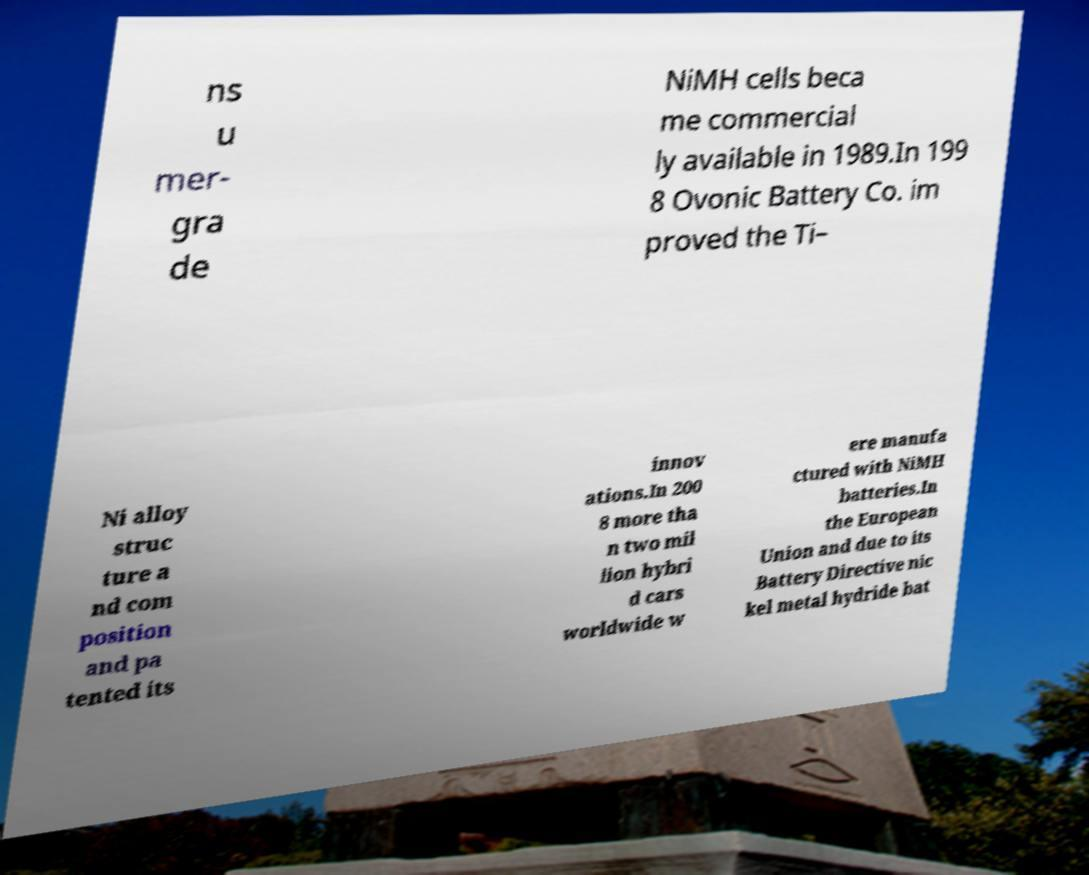I need the written content from this picture converted into text. Can you do that? ns u mer- gra de NiMH cells beca me commercial ly available in 1989.In 199 8 Ovonic Battery Co. im proved the Ti– Ni alloy struc ture a nd com position and pa tented its innov ations.In 200 8 more tha n two mil lion hybri d cars worldwide w ere manufa ctured with NiMH batteries.In the European Union and due to its Battery Directive nic kel metal hydride bat 